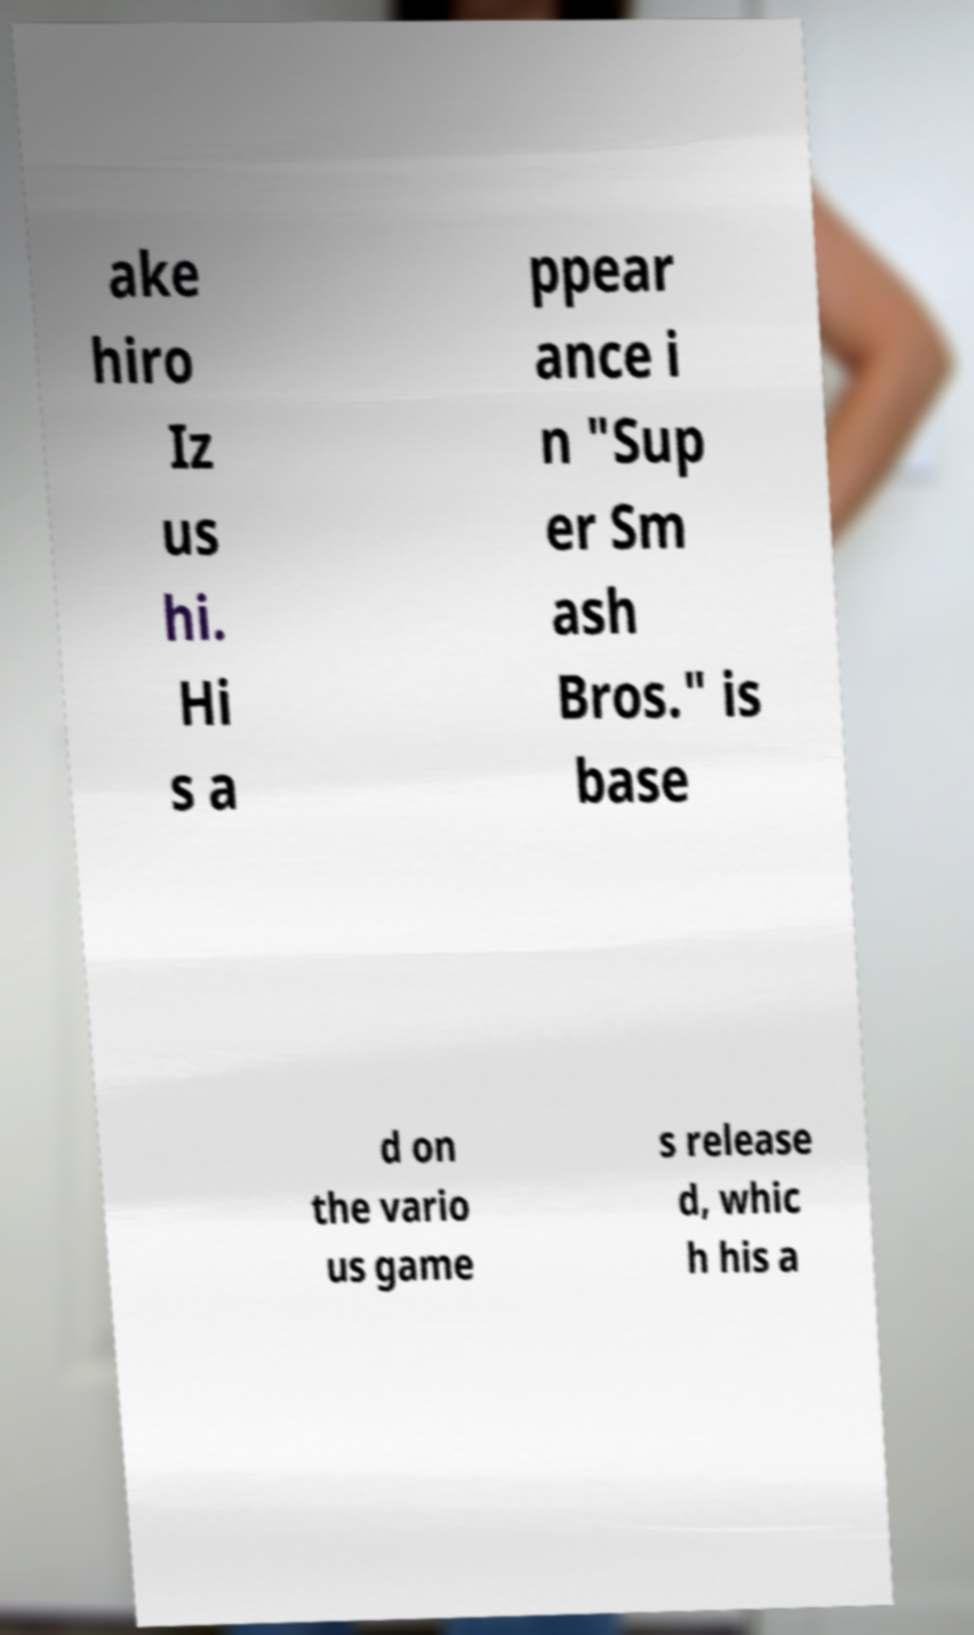What messages or text are displayed in this image? I need them in a readable, typed format. ake hiro Iz us hi. Hi s a ppear ance i n "Sup er Sm ash Bros." is base d on the vario us game s release d, whic h his a 